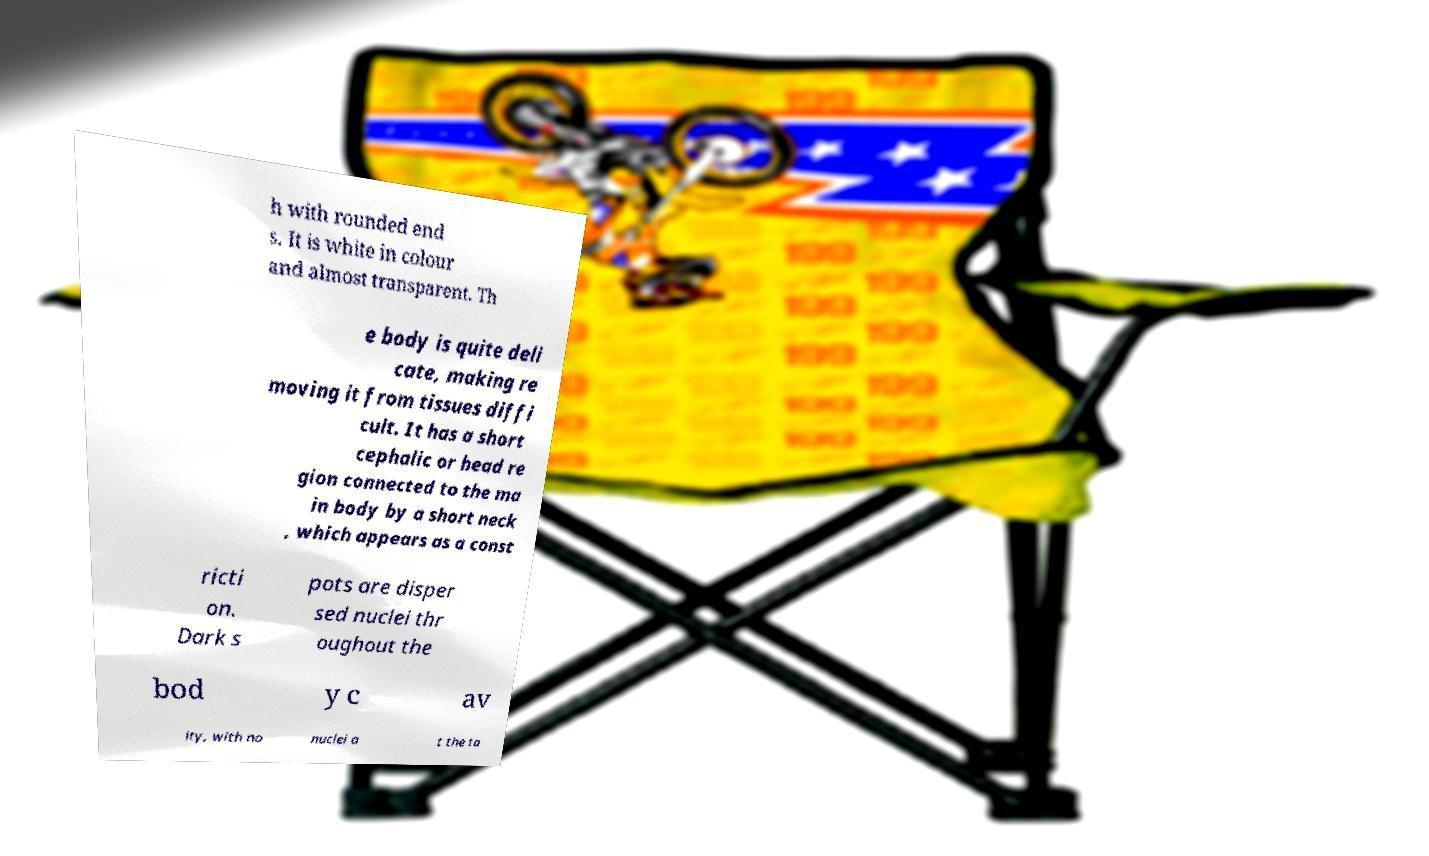Can you accurately transcribe the text from the provided image for me? h with rounded end s. It is white in colour and almost transparent. Th e body is quite deli cate, making re moving it from tissues diffi cult. It has a short cephalic or head re gion connected to the ma in body by a short neck , which appears as a const ricti on. Dark s pots are disper sed nuclei thr oughout the bod y c av ity, with no nuclei a t the ta 